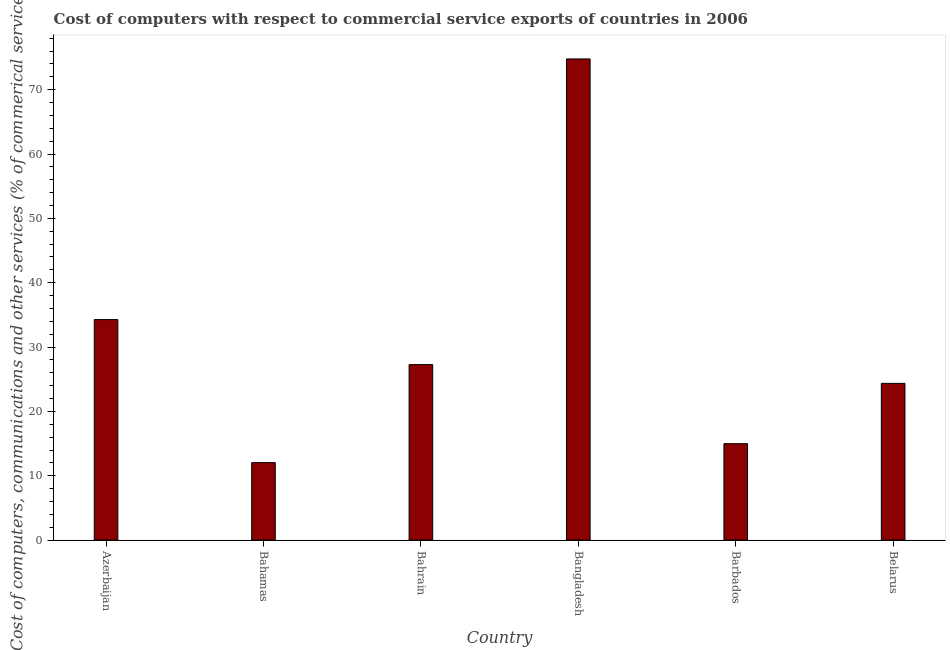What is the title of the graph?
Your answer should be very brief. Cost of computers with respect to commercial service exports of countries in 2006. What is the label or title of the X-axis?
Provide a short and direct response. Country. What is the label or title of the Y-axis?
Your response must be concise. Cost of computers, communications and other services (% of commerical service exports). What is the  computer and other services in Bangladesh?
Your response must be concise. 74.78. Across all countries, what is the maximum cost of communications?
Offer a terse response. 74.78. Across all countries, what is the minimum  computer and other services?
Provide a short and direct response. 12.04. In which country was the cost of communications maximum?
Provide a succinct answer. Bangladesh. In which country was the cost of communications minimum?
Keep it short and to the point. Bahamas. What is the sum of the cost of communications?
Make the answer very short. 187.71. What is the difference between the  computer and other services in Bahamas and Bahrain?
Your answer should be compact. -15.24. What is the average  computer and other services per country?
Make the answer very short. 31.29. What is the median  computer and other services?
Your answer should be very brief. 25.82. In how many countries, is the  computer and other services greater than 6 %?
Offer a terse response. 6. What is the ratio of the  computer and other services in Bahamas to that in Belarus?
Give a very brief answer. 0.49. Is the difference between the  computer and other services in Bahamas and Belarus greater than the difference between any two countries?
Provide a succinct answer. No. What is the difference between the highest and the second highest cost of communications?
Make the answer very short. 40.51. What is the difference between the highest and the lowest  computer and other services?
Offer a terse response. 62.74. How many bars are there?
Keep it short and to the point. 6. Are all the bars in the graph horizontal?
Provide a succinct answer. No. What is the difference between two consecutive major ticks on the Y-axis?
Ensure brevity in your answer.  10. Are the values on the major ticks of Y-axis written in scientific E-notation?
Keep it short and to the point. No. What is the Cost of computers, communications and other services (% of commerical service exports) in Azerbaijan?
Make the answer very short. 34.27. What is the Cost of computers, communications and other services (% of commerical service exports) of Bahamas?
Your answer should be compact. 12.04. What is the Cost of computers, communications and other services (% of commerical service exports) of Bahrain?
Make the answer very short. 27.28. What is the Cost of computers, communications and other services (% of commerical service exports) in Bangladesh?
Offer a terse response. 74.78. What is the Cost of computers, communications and other services (% of commerical service exports) in Barbados?
Your answer should be compact. 14.99. What is the Cost of computers, communications and other services (% of commerical service exports) of Belarus?
Your answer should be compact. 24.36. What is the difference between the Cost of computers, communications and other services (% of commerical service exports) in Azerbaijan and Bahamas?
Provide a short and direct response. 22.23. What is the difference between the Cost of computers, communications and other services (% of commerical service exports) in Azerbaijan and Bahrain?
Offer a very short reply. 6.99. What is the difference between the Cost of computers, communications and other services (% of commerical service exports) in Azerbaijan and Bangladesh?
Your answer should be compact. -40.51. What is the difference between the Cost of computers, communications and other services (% of commerical service exports) in Azerbaijan and Barbados?
Your answer should be very brief. 19.28. What is the difference between the Cost of computers, communications and other services (% of commerical service exports) in Azerbaijan and Belarus?
Your response must be concise. 9.91. What is the difference between the Cost of computers, communications and other services (% of commerical service exports) in Bahamas and Bahrain?
Provide a succinct answer. -15.24. What is the difference between the Cost of computers, communications and other services (% of commerical service exports) in Bahamas and Bangladesh?
Give a very brief answer. -62.74. What is the difference between the Cost of computers, communications and other services (% of commerical service exports) in Bahamas and Barbados?
Ensure brevity in your answer.  -2.95. What is the difference between the Cost of computers, communications and other services (% of commerical service exports) in Bahamas and Belarus?
Your answer should be compact. -12.32. What is the difference between the Cost of computers, communications and other services (% of commerical service exports) in Bahrain and Bangladesh?
Keep it short and to the point. -47.51. What is the difference between the Cost of computers, communications and other services (% of commerical service exports) in Bahrain and Barbados?
Ensure brevity in your answer.  12.29. What is the difference between the Cost of computers, communications and other services (% of commerical service exports) in Bahrain and Belarus?
Your answer should be compact. 2.92. What is the difference between the Cost of computers, communications and other services (% of commerical service exports) in Bangladesh and Barbados?
Offer a very short reply. 59.8. What is the difference between the Cost of computers, communications and other services (% of commerical service exports) in Bangladesh and Belarus?
Your answer should be compact. 50.42. What is the difference between the Cost of computers, communications and other services (% of commerical service exports) in Barbados and Belarus?
Offer a very short reply. -9.37. What is the ratio of the Cost of computers, communications and other services (% of commerical service exports) in Azerbaijan to that in Bahamas?
Offer a terse response. 2.85. What is the ratio of the Cost of computers, communications and other services (% of commerical service exports) in Azerbaijan to that in Bahrain?
Ensure brevity in your answer.  1.26. What is the ratio of the Cost of computers, communications and other services (% of commerical service exports) in Azerbaijan to that in Bangladesh?
Provide a short and direct response. 0.46. What is the ratio of the Cost of computers, communications and other services (% of commerical service exports) in Azerbaijan to that in Barbados?
Keep it short and to the point. 2.29. What is the ratio of the Cost of computers, communications and other services (% of commerical service exports) in Azerbaijan to that in Belarus?
Offer a terse response. 1.41. What is the ratio of the Cost of computers, communications and other services (% of commerical service exports) in Bahamas to that in Bahrain?
Your answer should be compact. 0.44. What is the ratio of the Cost of computers, communications and other services (% of commerical service exports) in Bahamas to that in Bangladesh?
Provide a succinct answer. 0.16. What is the ratio of the Cost of computers, communications and other services (% of commerical service exports) in Bahamas to that in Barbados?
Make the answer very short. 0.8. What is the ratio of the Cost of computers, communications and other services (% of commerical service exports) in Bahamas to that in Belarus?
Your answer should be very brief. 0.49. What is the ratio of the Cost of computers, communications and other services (% of commerical service exports) in Bahrain to that in Bangladesh?
Your answer should be very brief. 0.36. What is the ratio of the Cost of computers, communications and other services (% of commerical service exports) in Bahrain to that in Barbados?
Give a very brief answer. 1.82. What is the ratio of the Cost of computers, communications and other services (% of commerical service exports) in Bahrain to that in Belarus?
Ensure brevity in your answer.  1.12. What is the ratio of the Cost of computers, communications and other services (% of commerical service exports) in Bangladesh to that in Barbados?
Provide a short and direct response. 4.99. What is the ratio of the Cost of computers, communications and other services (% of commerical service exports) in Bangladesh to that in Belarus?
Your answer should be very brief. 3.07. What is the ratio of the Cost of computers, communications and other services (% of commerical service exports) in Barbados to that in Belarus?
Make the answer very short. 0.61. 